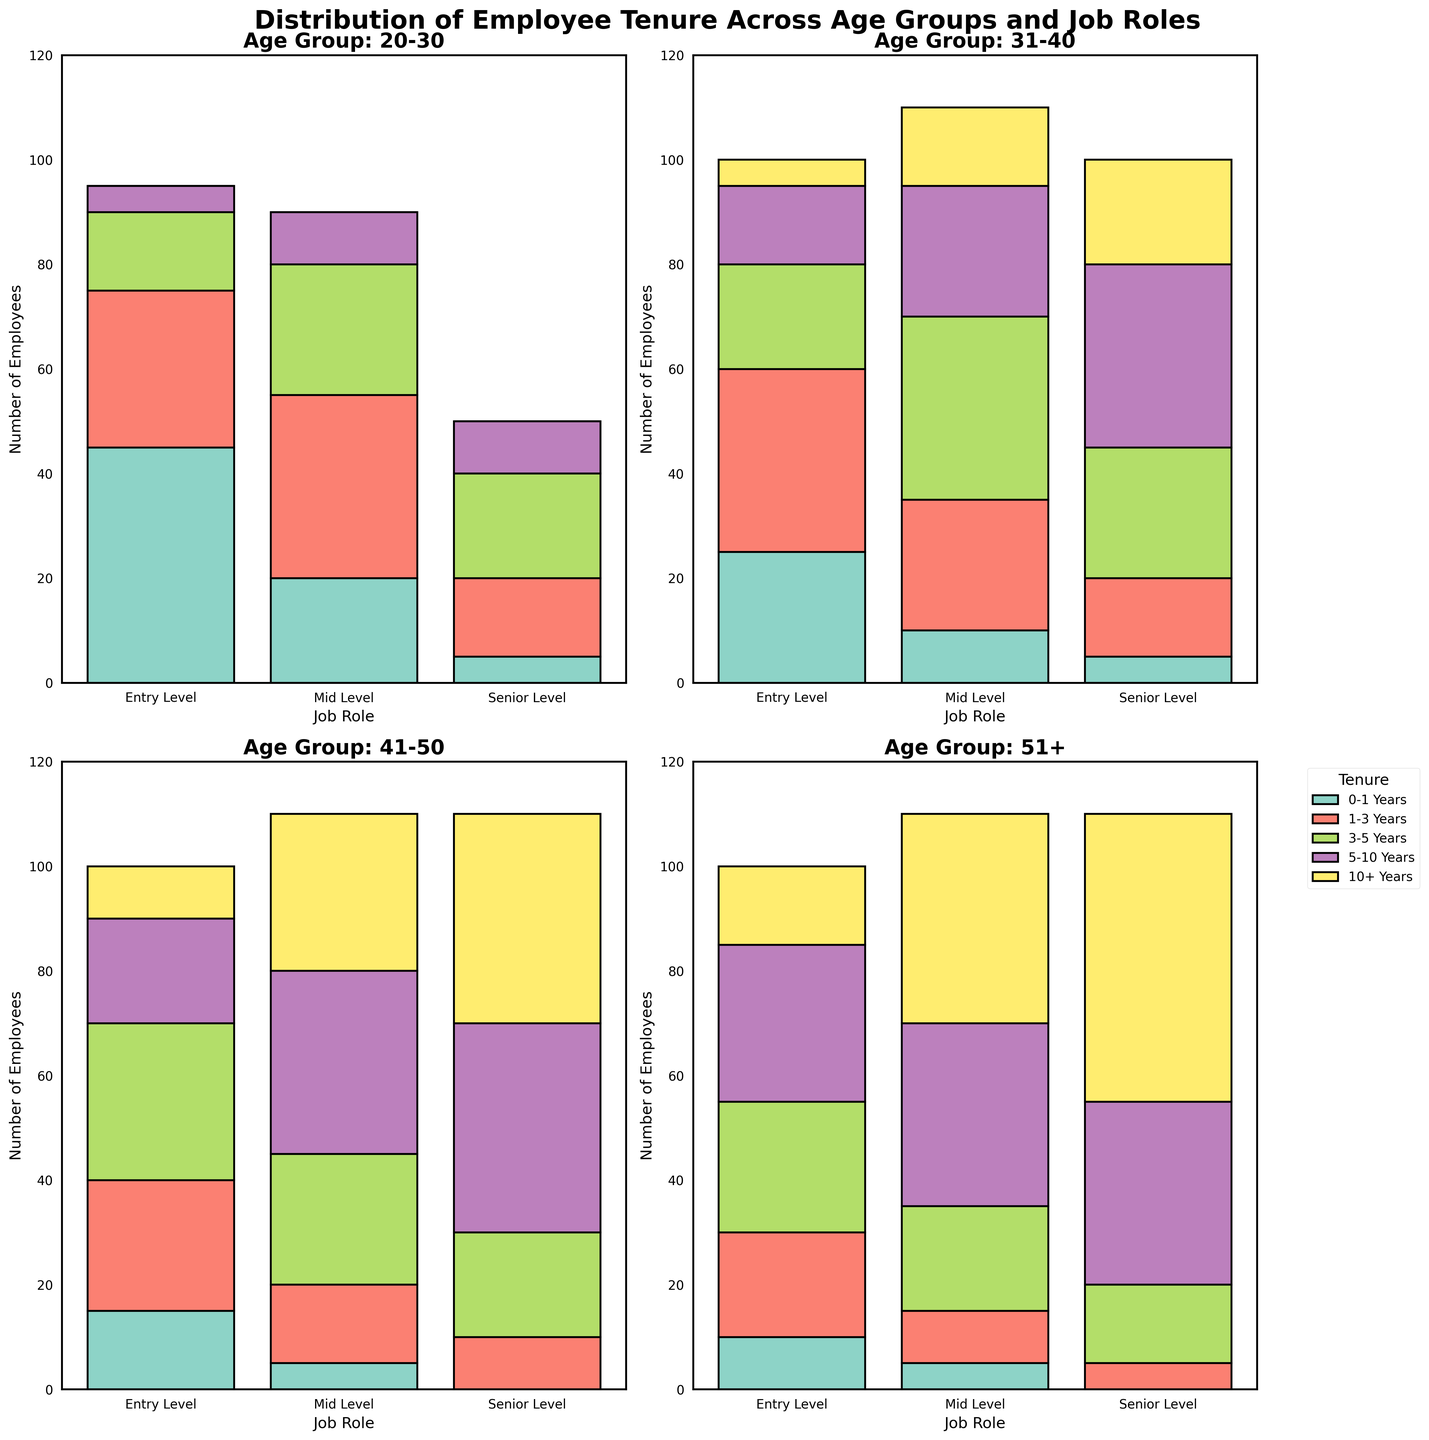What's the total number of employees aged 20-30 in Mid Level? To find the total number of employees aged 20-30 in Mid Level, sum the values for all tenure categories (0-1 Years, 1-3 Years, 3-5 Years, 5-10 Years). The data shows 20 + 35 + 25 + 10 = 90.
Answer: 90 Which age group has the highest number of employees with 10+ years of tenure in Entry Level? Compare the 10+ years of tenure values for Entry Level across all age groups. The age group 51+ has the highest value with 15 employees having 10+ years of tenure.
Answer: 51+ For the age group 31-40, which job role has the largest proportion of employees in the 3-5 years tenure category? Look at the values for 3-5 years of tenure in the age group 31-40. Mid Level has the highest number with 35 employees.
Answer: Mid Level How does the number of Senior Level employees aged 41-50 with 5-10 years of tenure compare to those aged 31-40 in the same job role and tenure category? For the 41-50 age group in Senior Level, there are 40 employees with 5-10 years of tenure. For the 31-40 age group in Senior Level, there are 35 employees. Therefore, there are more employees in the 41-50 group than in the 31-40 group.
Answer: 41-50 has more What's the average number of employees aged 20-30 in the 1-3 years tenure category across all job roles? Sum the number of employees in the 1-3 years tenure category for the 20-30 age group across all job roles and divide by the number of roles. The calculation is (30 + 35 + 15) / 3 = 80 / 3 ≈ 26.67.
Answer: ~26.67 Which job role and tenure category combination has the highest number of employees aged 51+? Look at the 51+ age group and find the highest value across all job roles and tenure categories. Senior Level with 10+ years of tenure has the highest value with 55 employees.
Answer: Senior Level, 10+ Years In the 20-30 age group, is there a job role where the number of employees decreases as tenure increases? Review the values for each tenure category in the 20-30 age group. For Entry Level, the number of employees decreases consistently with increased tenure: 45, 30, 15, 5, 0.
Answer: Yes, Entry Level Which age group and job role combination has the fewest employees in the 0-1 years tenure category? Compare the numbers in the 0-1 years tenure category across all job roles and age groups. Senior Level in the 41-50 age group has the fewest with 0 employees.
Answer: 41-50, Senior Level 